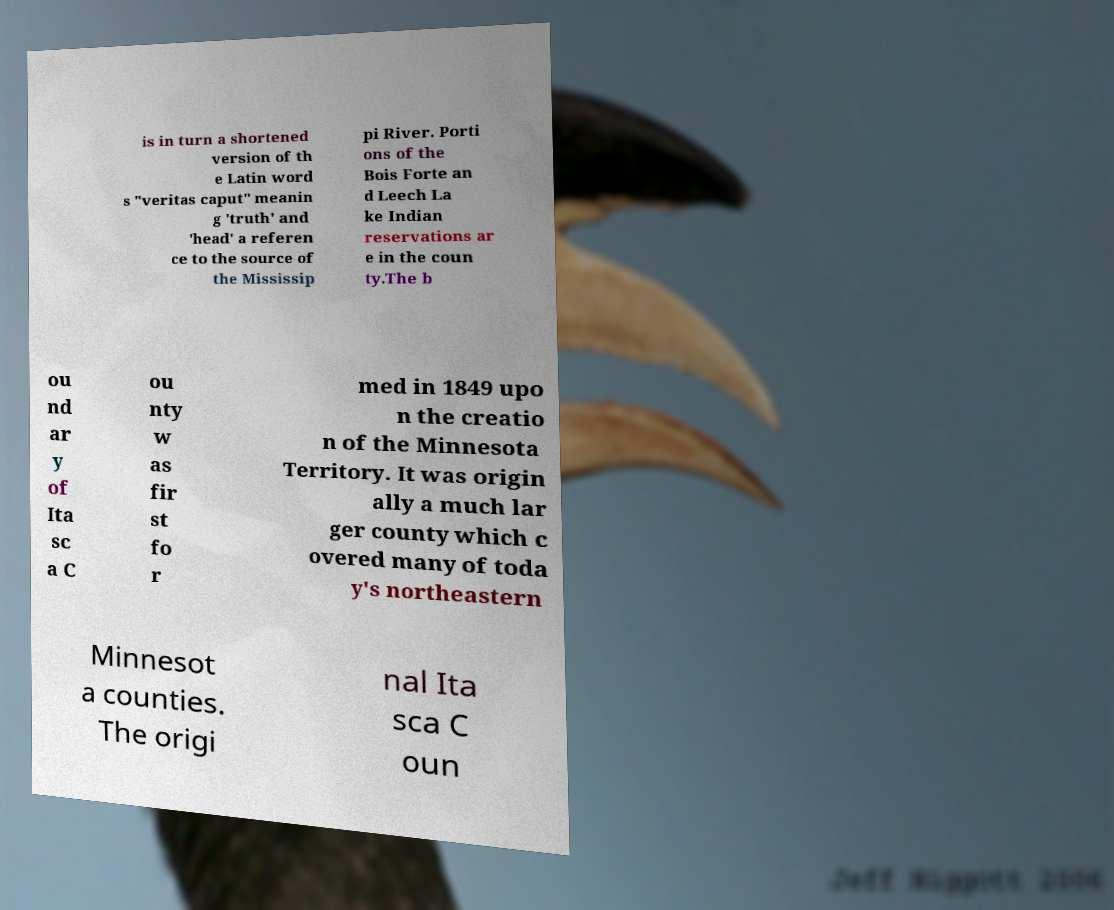Could you assist in decoding the text presented in this image and type it out clearly? is in turn a shortened version of th e Latin word s "veritas caput" meanin g 'truth' and 'head' a referen ce to the source of the Mississip pi River. Porti ons of the Bois Forte an d Leech La ke Indian reservations ar e in the coun ty.The b ou nd ar y of Ita sc a C ou nty w as fir st fo r med in 1849 upo n the creatio n of the Minnesota Territory. It was origin ally a much lar ger county which c overed many of toda y's northeastern Minnesot a counties. The origi nal Ita sca C oun 